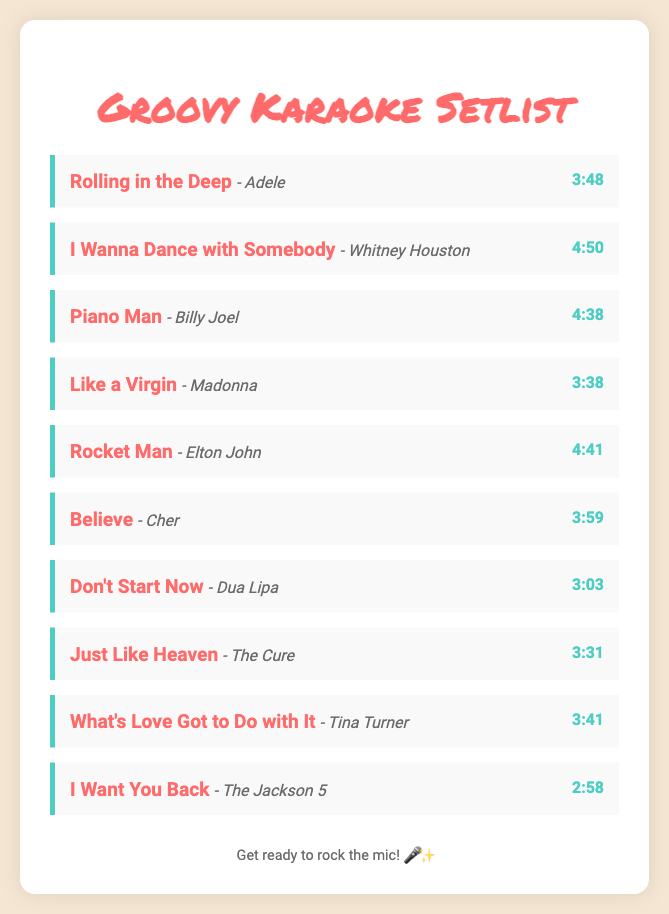What is the title of the first song in the setlist? The title of the first song is mentioned at the top of the list, which is "Rolling in the Deep."
Answer: Rolling in the Deep Who is the artist of "I Wanna Dance with Somebody"? The document specifies that the song "I Wanna Dance with Somebody" is performed by Whitney Houston.
Answer: Whitney Houston What is the duration of "Piano Man"? The duration is clearly displayed next to the song title, which shows it is 4 minutes and 38 seconds long.
Answer: 4:38 How many songs are listed in the setlist? The total number of songs can be counted from the list provided; there are 10 songs in total.
Answer: 10 Which song has the longest duration? To determine the song with the longest duration, we compare the durations listed; "I Wanna Dance with Somebody" is the longest at 4:50.
Answer: I Wanna Dance with Somebody What song comes after "Believe"? The song listed immediately after "Believe" in the setlist is "Don't Start Now."
Answer: Don't Start Now What genre do most songs in this setlist fall under? The setlist primarily features pop songs, as evidenced by the titles and artists selected.
Answer: Pop What is the color of the footer text? The footer text color is indicated in the styling section, which shows it is a shade of grey, specifically #6B6B6B.
Answer: Grey 